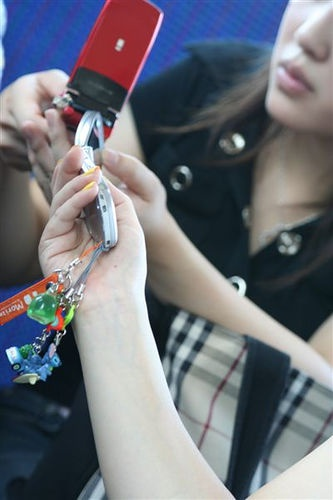Describe the objects in this image and their specific colors. I can see people in lightblue, black, gray, darkgray, and lightgray tones, people in lightblue, lightgray, darkgray, and gray tones, handbag in lightblue, darkgray, black, and gray tones, cell phone in lightblue, brown, black, purple, and maroon tones, and cell phone in lightblue, gray, and darkgray tones in this image. 